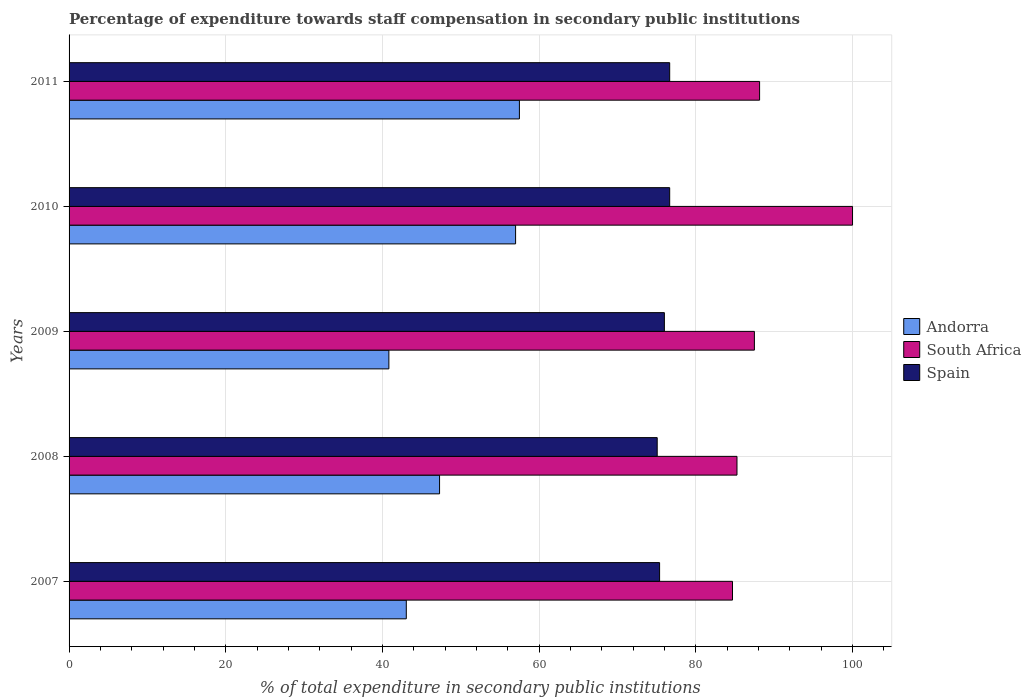How many groups of bars are there?
Your answer should be compact. 5. Are the number of bars per tick equal to the number of legend labels?
Your answer should be compact. Yes. How many bars are there on the 4th tick from the top?
Your answer should be compact. 3. How many bars are there on the 1st tick from the bottom?
Offer a terse response. 3. In how many cases, is the number of bars for a given year not equal to the number of legend labels?
Make the answer very short. 0. What is the percentage of expenditure towards staff compensation in South Africa in 2009?
Your answer should be compact. 87.47. Across all years, what is the minimum percentage of expenditure towards staff compensation in Spain?
Offer a very short reply. 75.07. In which year was the percentage of expenditure towards staff compensation in Andorra maximum?
Your answer should be very brief. 2011. What is the total percentage of expenditure towards staff compensation in South Africa in the graph?
Your answer should be compact. 445.54. What is the difference between the percentage of expenditure towards staff compensation in Andorra in 2007 and that in 2011?
Keep it short and to the point. -14.44. What is the difference between the percentage of expenditure towards staff compensation in Andorra in 2010 and the percentage of expenditure towards staff compensation in Spain in 2008?
Your answer should be very brief. -18.07. What is the average percentage of expenditure towards staff compensation in Spain per year?
Offer a very short reply. 75.95. In the year 2008, what is the difference between the percentage of expenditure towards staff compensation in Spain and percentage of expenditure towards staff compensation in South Africa?
Ensure brevity in your answer.  -10.18. In how many years, is the percentage of expenditure towards staff compensation in Spain greater than 16 %?
Provide a succinct answer. 5. What is the ratio of the percentage of expenditure towards staff compensation in South Africa in 2008 to that in 2011?
Keep it short and to the point. 0.97. What is the difference between the highest and the lowest percentage of expenditure towards staff compensation in Spain?
Your answer should be very brief. 1.59. How many bars are there?
Ensure brevity in your answer.  15. How many years are there in the graph?
Offer a very short reply. 5. Are the values on the major ticks of X-axis written in scientific E-notation?
Your answer should be compact. No. Does the graph contain any zero values?
Offer a terse response. No. Does the graph contain grids?
Your answer should be very brief. Yes. Where does the legend appear in the graph?
Offer a terse response. Center right. How many legend labels are there?
Ensure brevity in your answer.  3. How are the legend labels stacked?
Ensure brevity in your answer.  Vertical. What is the title of the graph?
Offer a very short reply. Percentage of expenditure towards staff compensation in secondary public institutions. What is the label or title of the X-axis?
Offer a terse response. % of total expenditure in secondary public institutions. What is the label or title of the Y-axis?
Keep it short and to the point. Years. What is the % of total expenditure in secondary public institutions in Andorra in 2007?
Your answer should be very brief. 43.04. What is the % of total expenditure in secondary public institutions of South Africa in 2007?
Provide a short and direct response. 84.68. What is the % of total expenditure in secondary public institutions of Spain in 2007?
Your answer should be compact. 75.37. What is the % of total expenditure in secondary public institutions of Andorra in 2008?
Your answer should be very brief. 47.29. What is the % of total expenditure in secondary public institutions of South Africa in 2008?
Your answer should be compact. 85.25. What is the % of total expenditure in secondary public institutions in Spain in 2008?
Your answer should be compact. 75.07. What is the % of total expenditure in secondary public institutions in Andorra in 2009?
Your answer should be compact. 40.82. What is the % of total expenditure in secondary public institutions in South Africa in 2009?
Offer a terse response. 87.47. What is the % of total expenditure in secondary public institutions of Spain in 2009?
Give a very brief answer. 75.98. What is the % of total expenditure in secondary public institutions in Andorra in 2010?
Offer a very short reply. 56.99. What is the % of total expenditure in secondary public institutions of Spain in 2010?
Provide a succinct answer. 76.66. What is the % of total expenditure in secondary public institutions of Andorra in 2011?
Your response must be concise. 57.48. What is the % of total expenditure in secondary public institutions of South Africa in 2011?
Provide a succinct answer. 88.14. What is the % of total expenditure in secondary public institutions of Spain in 2011?
Offer a very short reply. 76.66. Across all years, what is the maximum % of total expenditure in secondary public institutions of Andorra?
Keep it short and to the point. 57.48. Across all years, what is the maximum % of total expenditure in secondary public institutions of Spain?
Your answer should be very brief. 76.66. Across all years, what is the minimum % of total expenditure in secondary public institutions of Andorra?
Your answer should be very brief. 40.82. Across all years, what is the minimum % of total expenditure in secondary public institutions in South Africa?
Ensure brevity in your answer.  84.68. Across all years, what is the minimum % of total expenditure in secondary public institutions in Spain?
Make the answer very short. 75.07. What is the total % of total expenditure in secondary public institutions of Andorra in the graph?
Offer a very short reply. 245.62. What is the total % of total expenditure in secondary public institutions of South Africa in the graph?
Give a very brief answer. 445.54. What is the total % of total expenditure in secondary public institutions in Spain in the graph?
Offer a terse response. 379.75. What is the difference between the % of total expenditure in secondary public institutions of Andorra in 2007 and that in 2008?
Offer a terse response. -4.25. What is the difference between the % of total expenditure in secondary public institutions of South Africa in 2007 and that in 2008?
Offer a very short reply. -0.57. What is the difference between the % of total expenditure in secondary public institutions in Spain in 2007 and that in 2008?
Provide a succinct answer. 0.3. What is the difference between the % of total expenditure in secondary public institutions of Andorra in 2007 and that in 2009?
Offer a very short reply. 2.22. What is the difference between the % of total expenditure in secondary public institutions of South Africa in 2007 and that in 2009?
Offer a very short reply. -2.79. What is the difference between the % of total expenditure in secondary public institutions in Spain in 2007 and that in 2009?
Provide a succinct answer. -0.61. What is the difference between the % of total expenditure in secondary public institutions in Andorra in 2007 and that in 2010?
Ensure brevity in your answer.  -13.95. What is the difference between the % of total expenditure in secondary public institutions of South Africa in 2007 and that in 2010?
Offer a very short reply. -15.32. What is the difference between the % of total expenditure in secondary public institutions in Spain in 2007 and that in 2010?
Your answer should be very brief. -1.29. What is the difference between the % of total expenditure in secondary public institutions in Andorra in 2007 and that in 2011?
Your answer should be compact. -14.44. What is the difference between the % of total expenditure in secondary public institutions in South Africa in 2007 and that in 2011?
Make the answer very short. -3.46. What is the difference between the % of total expenditure in secondary public institutions of Spain in 2007 and that in 2011?
Your response must be concise. -1.29. What is the difference between the % of total expenditure in secondary public institutions of Andorra in 2008 and that in 2009?
Ensure brevity in your answer.  6.47. What is the difference between the % of total expenditure in secondary public institutions in South Africa in 2008 and that in 2009?
Keep it short and to the point. -2.22. What is the difference between the % of total expenditure in secondary public institutions in Spain in 2008 and that in 2009?
Make the answer very short. -0.92. What is the difference between the % of total expenditure in secondary public institutions in Andorra in 2008 and that in 2010?
Offer a very short reply. -9.71. What is the difference between the % of total expenditure in secondary public institutions of South Africa in 2008 and that in 2010?
Offer a terse response. -14.75. What is the difference between the % of total expenditure in secondary public institutions of Spain in 2008 and that in 2010?
Offer a terse response. -1.59. What is the difference between the % of total expenditure in secondary public institutions of Andorra in 2008 and that in 2011?
Your answer should be compact. -10.19. What is the difference between the % of total expenditure in secondary public institutions in South Africa in 2008 and that in 2011?
Your answer should be very brief. -2.89. What is the difference between the % of total expenditure in secondary public institutions of Spain in 2008 and that in 2011?
Your answer should be very brief. -1.59. What is the difference between the % of total expenditure in secondary public institutions of Andorra in 2009 and that in 2010?
Keep it short and to the point. -16.18. What is the difference between the % of total expenditure in secondary public institutions in South Africa in 2009 and that in 2010?
Keep it short and to the point. -12.53. What is the difference between the % of total expenditure in secondary public institutions in Spain in 2009 and that in 2010?
Offer a very short reply. -0.68. What is the difference between the % of total expenditure in secondary public institutions of Andorra in 2009 and that in 2011?
Offer a terse response. -16.66. What is the difference between the % of total expenditure in secondary public institutions in South Africa in 2009 and that in 2011?
Offer a very short reply. -0.66. What is the difference between the % of total expenditure in secondary public institutions in Spain in 2009 and that in 2011?
Make the answer very short. -0.68. What is the difference between the % of total expenditure in secondary public institutions in Andorra in 2010 and that in 2011?
Provide a short and direct response. -0.49. What is the difference between the % of total expenditure in secondary public institutions in South Africa in 2010 and that in 2011?
Make the answer very short. 11.86. What is the difference between the % of total expenditure in secondary public institutions in Andorra in 2007 and the % of total expenditure in secondary public institutions in South Africa in 2008?
Offer a very short reply. -42.21. What is the difference between the % of total expenditure in secondary public institutions of Andorra in 2007 and the % of total expenditure in secondary public institutions of Spain in 2008?
Provide a succinct answer. -32.03. What is the difference between the % of total expenditure in secondary public institutions of South Africa in 2007 and the % of total expenditure in secondary public institutions of Spain in 2008?
Provide a short and direct response. 9.61. What is the difference between the % of total expenditure in secondary public institutions of Andorra in 2007 and the % of total expenditure in secondary public institutions of South Africa in 2009?
Provide a succinct answer. -44.43. What is the difference between the % of total expenditure in secondary public institutions of Andorra in 2007 and the % of total expenditure in secondary public institutions of Spain in 2009?
Ensure brevity in your answer.  -32.94. What is the difference between the % of total expenditure in secondary public institutions of South Africa in 2007 and the % of total expenditure in secondary public institutions of Spain in 2009?
Keep it short and to the point. 8.69. What is the difference between the % of total expenditure in secondary public institutions of Andorra in 2007 and the % of total expenditure in secondary public institutions of South Africa in 2010?
Ensure brevity in your answer.  -56.96. What is the difference between the % of total expenditure in secondary public institutions in Andorra in 2007 and the % of total expenditure in secondary public institutions in Spain in 2010?
Make the answer very short. -33.62. What is the difference between the % of total expenditure in secondary public institutions in South Africa in 2007 and the % of total expenditure in secondary public institutions in Spain in 2010?
Provide a succinct answer. 8.02. What is the difference between the % of total expenditure in secondary public institutions of Andorra in 2007 and the % of total expenditure in secondary public institutions of South Africa in 2011?
Keep it short and to the point. -45.09. What is the difference between the % of total expenditure in secondary public institutions of Andorra in 2007 and the % of total expenditure in secondary public institutions of Spain in 2011?
Provide a short and direct response. -33.62. What is the difference between the % of total expenditure in secondary public institutions in South Africa in 2007 and the % of total expenditure in secondary public institutions in Spain in 2011?
Your response must be concise. 8.02. What is the difference between the % of total expenditure in secondary public institutions of Andorra in 2008 and the % of total expenditure in secondary public institutions of South Africa in 2009?
Offer a terse response. -40.19. What is the difference between the % of total expenditure in secondary public institutions in Andorra in 2008 and the % of total expenditure in secondary public institutions in Spain in 2009?
Your response must be concise. -28.7. What is the difference between the % of total expenditure in secondary public institutions of South Africa in 2008 and the % of total expenditure in secondary public institutions of Spain in 2009?
Provide a succinct answer. 9.27. What is the difference between the % of total expenditure in secondary public institutions in Andorra in 2008 and the % of total expenditure in secondary public institutions in South Africa in 2010?
Keep it short and to the point. -52.71. What is the difference between the % of total expenditure in secondary public institutions of Andorra in 2008 and the % of total expenditure in secondary public institutions of Spain in 2010?
Your answer should be very brief. -29.37. What is the difference between the % of total expenditure in secondary public institutions in South Africa in 2008 and the % of total expenditure in secondary public institutions in Spain in 2010?
Provide a succinct answer. 8.59. What is the difference between the % of total expenditure in secondary public institutions in Andorra in 2008 and the % of total expenditure in secondary public institutions in South Africa in 2011?
Provide a short and direct response. -40.85. What is the difference between the % of total expenditure in secondary public institutions of Andorra in 2008 and the % of total expenditure in secondary public institutions of Spain in 2011?
Keep it short and to the point. -29.37. What is the difference between the % of total expenditure in secondary public institutions of South Africa in 2008 and the % of total expenditure in secondary public institutions of Spain in 2011?
Make the answer very short. 8.59. What is the difference between the % of total expenditure in secondary public institutions of Andorra in 2009 and the % of total expenditure in secondary public institutions of South Africa in 2010?
Keep it short and to the point. -59.18. What is the difference between the % of total expenditure in secondary public institutions of Andorra in 2009 and the % of total expenditure in secondary public institutions of Spain in 2010?
Your answer should be very brief. -35.84. What is the difference between the % of total expenditure in secondary public institutions of South Africa in 2009 and the % of total expenditure in secondary public institutions of Spain in 2010?
Make the answer very short. 10.81. What is the difference between the % of total expenditure in secondary public institutions in Andorra in 2009 and the % of total expenditure in secondary public institutions in South Africa in 2011?
Your answer should be compact. -47.32. What is the difference between the % of total expenditure in secondary public institutions in Andorra in 2009 and the % of total expenditure in secondary public institutions in Spain in 2011?
Give a very brief answer. -35.84. What is the difference between the % of total expenditure in secondary public institutions in South Africa in 2009 and the % of total expenditure in secondary public institutions in Spain in 2011?
Your answer should be compact. 10.81. What is the difference between the % of total expenditure in secondary public institutions of Andorra in 2010 and the % of total expenditure in secondary public institutions of South Africa in 2011?
Offer a terse response. -31.14. What is the difference between the % of total expenditure in secondary public institutions of Andorra in 2010 and the % of total expenditure in secondary public institutions of Spain in 2011?
Give a very brief answer. -19.67. What is the difference between the % of total expenditure in secondary public institutions of South Africa in 2010 and the % of total expenditure in secondary public institutions of Spain in 2011?
Your response must be concise. 23.34. What is the average % of total expenditure in secondary public institutions of Andorra per year?
Provide a succinct answer. 49.12. What is the average % of total expenditure in secondary public institutions of South Africa per year?
Keep it short and to the point. 89.11. What is the average % of total expenditure in secondary public institutions in Spain per year?
Offer a terse response. 75.95. In the year 2007, what is the difference between the % of total expenditure in secondary public institutions of Andorra and % of total expenditure in secondary public institutions of South Africa?
Provide a succinct answer. -41.64. In the year 2007, what is the difference between the % of total expenditure in secondary public institutions of Andorra and % of total expenditure in secondary public institutions of Spain?
Provide a short and direct response. -32.33. In the year 2007, what is the difference between the % of total expenditure in secondary public institutions in South Africa and % of total expenditure in secondary public institutions in Spain?
Ensure brevity in your answer.  9.31. In the year 2008, what is the difference between the % of total expenditure in secondary public institutions of Andorra and % of total expenditure in secondary public institutions of South Africa?
Provide a succinct answer. -37.96. In the year 2008, what is the difference between the % of total expenditure in secondary public institutions in Andorra and % of total expenditure in secondary public institutions in Spain?
Make the answer very short. -27.78. In the year 2008, what is the difference between the % of total expenditure in secondary public institutions of South Africa and % of total expenditure in secondary public institutions of Spain?
Your answer should be compact. 10.18. In the year 2009, what is the difference between the % of total expenditure in secondary public institutions in Andorra and % of total expenditure in secondary public institutions in South Africa?
Your answer should be compact. -46.66. In the year 2009, what is the difference between the % of total expenditure in secondary public institutions of Andorra and % of total expenditure in secondary public institutions of Spain?
Offer a very short reply. -35.17. In the year 2009, what is the difference between the % of total expenditure in secondary public institutions of South Africa and % of total expenditure in secondary public institutions of Spain?
Ensure brevity in your answer.  11.49. In the year 2010, what is the difference between the % of total expenditure in secondary public institutions of Andorra and % of total expenditure in secondary public institutions of South Africa?
Keep it short and to the point. -43.01. In the year 2010, what is the difference between the % of total expenditure in secondary public institutions in Andorra and % of total expenditure in secondary public institutions in Spain?
Your response must be concise. -19.67. In the year 2010, what is the difference between the % of total expenditure in secondary public institutions of South Africa and % of total expenditure in secondary public institutions of Spain?
Provide a succinct answer. 23.34. In the year 2011, what is the difference between the % of total expenditure in secondary public institutions of Andorra and % of total expenditure in secondary public institutions of South Africa?
Your answer should be compact. -30.66. In the year 2011, what is the difference between the % of total expenditure in secondary public institutions in Andorra and % of total expenditure in secondary public institutions in Spain?
Your response must be concise. -19.18. In the year 2011, what is the difference between the % of total expenditure in secondary public institutions of South Africa and % of total expenditure in secondary public institutions of Spain?
Offer a terse response. 11.48. What is the ratio of the % of total expenditure in secondary public institutions of Andorra in 2007 to that in 2008?
Make the answer very short. 0.91. What is the ratio of the % of total expenditure in secondary public institutions of South Africa in 2007 to that in 2008?
Offer a terse response. 0.99. What is the ratio of the % of total expenditure in secondary public institutions in Andorra in 2007 to that in 2009?
Your answer should be compact. 1.05. What is the ratio of the % of total expenditure in secondary public institutions in South Africa in 2007 to that in 2009?
Your answer should be very brief. 0.97. What is the ratio of the % of total expenditure in secondary public institutions of Andorra in 2007 to that in 2010?
Provide a short and direct response. 0.76. What is the ratio of the % of total expenditure in secondary public institutions in South Africa in 2007 to that in 2010?
Ensure brevity in your answer.  0.85. What is the ratio of the % of total expenditure in secondary public institutions in Spain in 2007 to that in 2010?
Offer a very short reply. 0.98. What is the ratio of the % of total expenditure in secondary public institutions in Andorra in 2007 to that in 2011?
Keep it short and to the point. 0.75. What is the ratio of the % of total expenditure in secondary public institutions in South Africa in 2007 to that in 2011?
Give a very brief answer. 0.96. What is the ratio of the % of total expenditure in secondary public institutions of Spain in 2007 to that in 2011?
Offer a very short reply. 0.98. What is the ratio of the % of total expenditure in secondary public institutions of Andorra in 2008 to that in 2009?
Provide a short and direct response. 1.16. What is the ratio of the % of total expenditure in secondary public institutions in South Africa in 2008 to that in 2009?
Offer a terse response. 0.97. What is the ratio of the % of total expenditure in secondary public institutions of Spain in 2008 to that in 2009?
Give a very brief answer. 0.99. What is the ratio of the % of total expenditure in secondary public institutions in Andorra in 2008 to that in 2010?
Provide a short and direct response. 0.83. What is the ratio of the % of total expenditure in secondary public institutions in South Africa in 2008 to that in 2010?
Provide a short and direct response. 0.85. What is the ratio of the % of total expenditure in secondary public institutions of Spain in 2008 to that in 2010?
Your answer should be very brief. 0.98. What is the ratio of the % of total expenditure in secondary public institutions in Andorra in 2008 to that in 2011?
Your answer should be compact. 0.82. What is the ratio of the % of total expenditure in secondary public institutions of South Africa in 2008 to that in 2011?
Your answer should be very brief. 0.97. What is the ratio of the % of total expenditure in secondary public institutions in Spain in 2008 to that in 2011?
Give a very brief answer. 0.98. What is the ratio of the % of total expenditure in secondary public institutions in Andorra in 2009 to that in 2010?
Your response must be concise. 0.72. What is the ratio of the % of total expenditure in secondary public institutions of South Africa in 2009 to that in 2010?
Make the answer very short. 0.87. What is the ratio of the % of total expenditure in secondary public institutions of Spain in 2009 to that in 2010?
Ensure brevity in your answer.  0.99. What is the ratio of the % of total expenditure in secondary public institutions in Andorra in 2009 to that in 2011?
Offer a very short reply. 0.71. What is the ratio of the % of total expenditure in secondary public institutions in Spain in 2009 to that in 2011?
Make the answer very short. 0.99. What is the ratio of the % of total expenditure in secondary public institutions of South Africa in 2010 to that in 2011?
Keep it short and to the point. 1.13. What is the ratio of the % of total expenditure in secondary public institutions in Spain in 2010 to that in 2011?
Keep it short and to the point. 1. What is the difference between the highest and the second highest % of total expenditure in secondary public institutions of Andorra?
Keep it short and to the point. 0.49. What is the difference between the highest and the second highest % of total expenditure in secondary public institutions of South Africa?
Your answer should be compact. 11.86. What is the difference between the highest and the second highest % of total expenditure in secondary public institutions in Spain?
Offer a terse response. 0. What is the difference between the highest and the lowest % of total expenditure in secondary public institutions of Andorra?
Your answer should be very brief. 16.66. What is the difference between the highest and the lowest % of total expenditure in secondary public institutions in South Africa?
Keep it short and to the point. 15.32. What is the difference between the highest and the lowest % of total expenditure in secondary public institutions in Spain?
Provide a succinct answer. 1.59. 